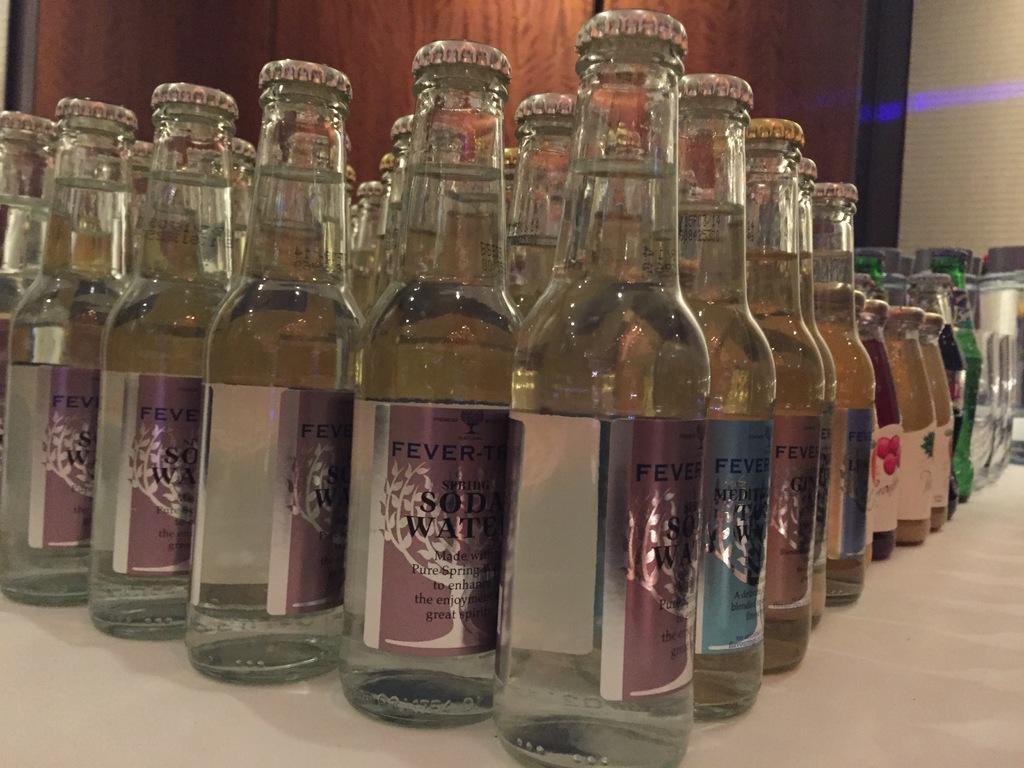What kind of water is in the bottles?
Keep it short and to the point. Soda water. 